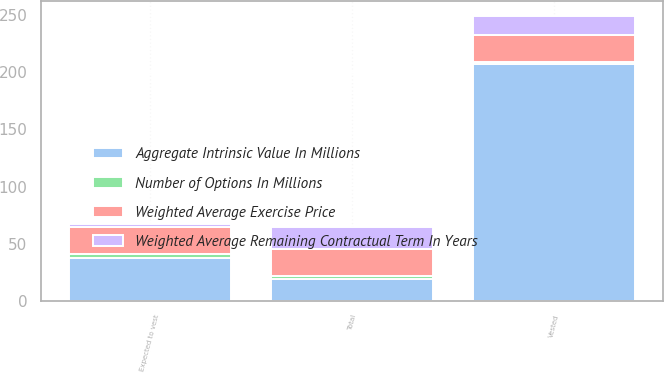<chart> <loc_0><loc_0><loc_500><loc_500><stacked_bar_chart><ecel><fcel>Vested<fcel>Expected to vest<fcel>Total<nl><fcel>Weighted Average Remaining Contractual Term In Years<fcel>16.6<fcel>2.9<fcel>19.5<nl><fcel>Weighted Average Exercise Price<fcel>23.81<fcel>23.33<fcel>23.74<nl><fcel>Number of Options In Millions<fcel>2.1<fcel>3.3<fcel>2.3<nl><fcel>Aggregate Intrinsic Value In Millions<fcel>207<fcel>38<fcel>19.5<nl></chart> 